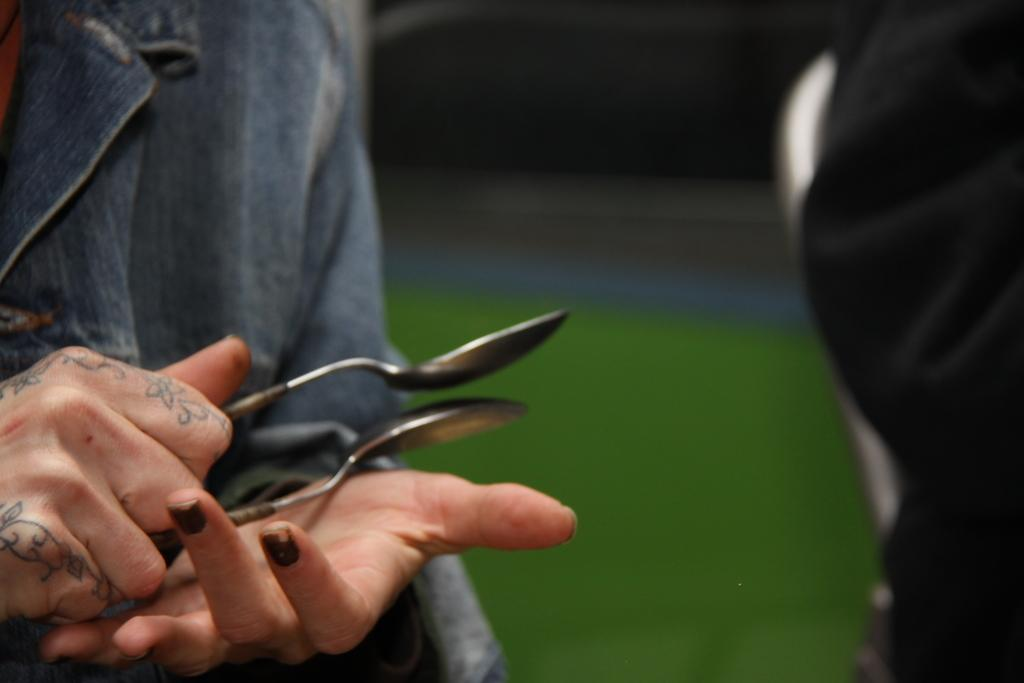What is the main subject of the image? There is a person in the image. What is the person holding in their hand? The person is holding two spoons in their hand. Where is the locket that the person is wearing in the image? There is no mention of a locket in the image, so it cannot be determined if the person is wearing one. 